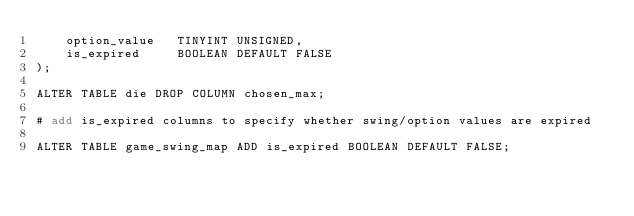Convert code to text. <code><loc_0><loc_0><loc_500><loc_500><_SQL_>    option_value   TINYINT UNSIGNED,
    is_expired     BOOLEAN DEFAULT FALSE
);

ALTER TABLE die DROP COLUMN chosen_max;

# add is_expired columns to specify whether swing/option values are expired

ALTER TABLE game_swing_map ADD is_expired BOOLEAN DEFAULT FALSE;

</code> 